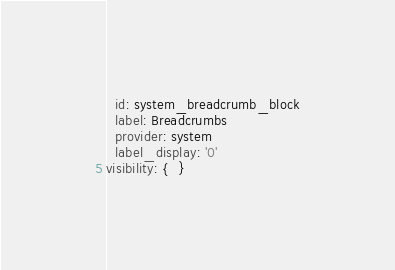<code> <loc_0><loc_0><loc_500><loc_500><_YAML_>  id: system_breadcrumb_block
  label: Breadcrumbs
  provider: system
  label_display: '0'
visibility: {  }
</code> 